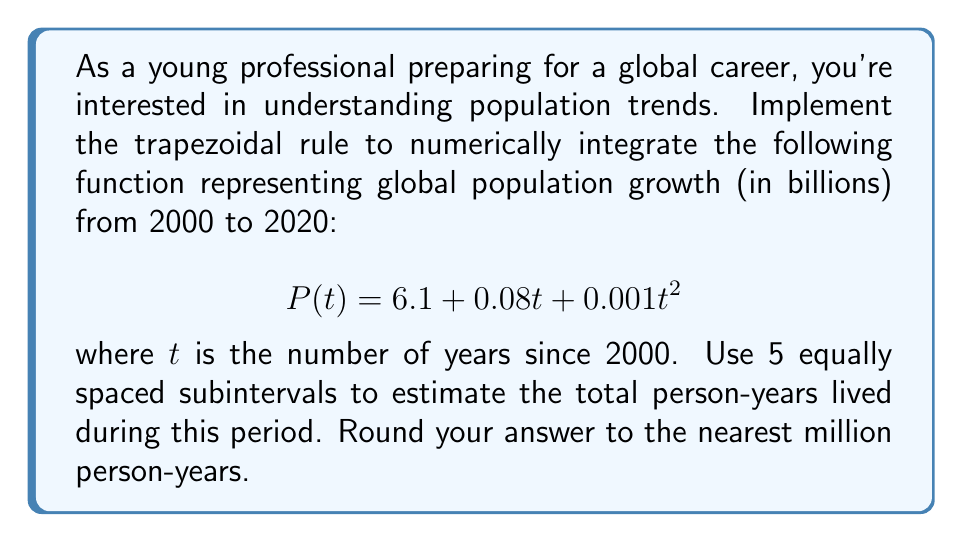Help me with this question. To solve this problem using the trapezoidal rule, we'll follow these steps:

1) The trapezoidal rule for $n$ subintervals is given by:

   $$\int_{a}^{b} f(x) dx \approx \frac{h}{2}[f(x_0) + 2f(x_1) + 2f(x_2) + ... + 2f(x_{n-1}) + f(x_n)]$$

   where $h = \frac{b-a}{n}$, and $x_i = a + ih$ for $i = 0, 1, ..., n$

2) In our case:
   $a = 0$, $b = 20$, $n = 5$
   $h = \frac{20-0}{5} = 4$

3) We need to evaluate $P(t)$ at $t = 0, 4, 8, 12, 16, 20$:

   $P(0) = 6.1 + 0.08(0) + 0.001(0)^2 = 6.1$
   $P(4) = 6.1 + 0.08(4) + 0.001(4)^2 = 6.536$
   $P(8) = 6.1 + 0.08(8) + 0.001(8)^2 = 7.024$
   $P(12) = 6.1 + 0.08(12) + 0.001(12)^2 = 7.564$
   $P(16) = 6.1 + 0.08(16) + 0.001(16)^2 = 8.156$
   $P(20) = 6.1 + 0.08(20) + 0.001(20)^2 = 8.8$

4) Applying the trapezoidal rule:

   $$\int_{0}^{20} P(t) dt \approx \frac{4}{2}[6.1 + 2(6.536) + 2(7.024) + 2(7.564) + 2(8.156) + 8.8]$$

5) Calculating:

   $$= 2[6.1 + 13.072 + 14.048 + 15.128 + 16.312 + 8.8]$$
   $$= 2(73.46) = 146.92$$

6) The result 146.92 represents billion person-years. Converting to million person-years:

   $146.92 \times 1000 = 146,920$ million person-years

7) Rounding to the nearest million:

   $146,920$ rounds to $146,920$ million person-years
Answer: 146,920 million person-years 